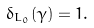<formula> <loc_0><loc_0><loc_500><loc_500>\delta _ { L _ { 0 } } ( \gamma ) = 1 .</formula> 